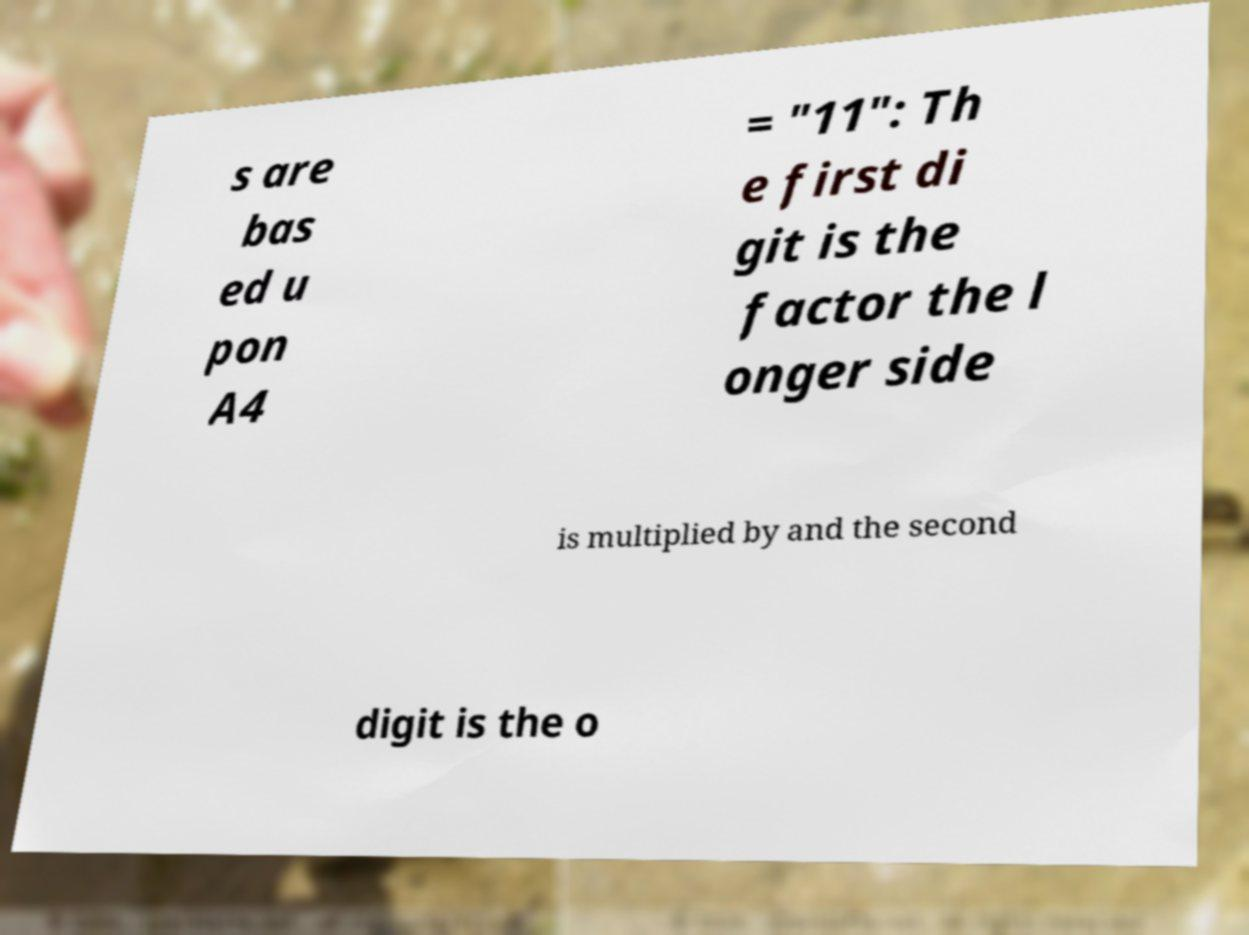There's text embedded in this image that I need extracted. Can you transcribe it verbatim? s are bas ed u pon A4 = "11": Th e first di git is the factor the l onger side is multiplied by and the second digit is the o 